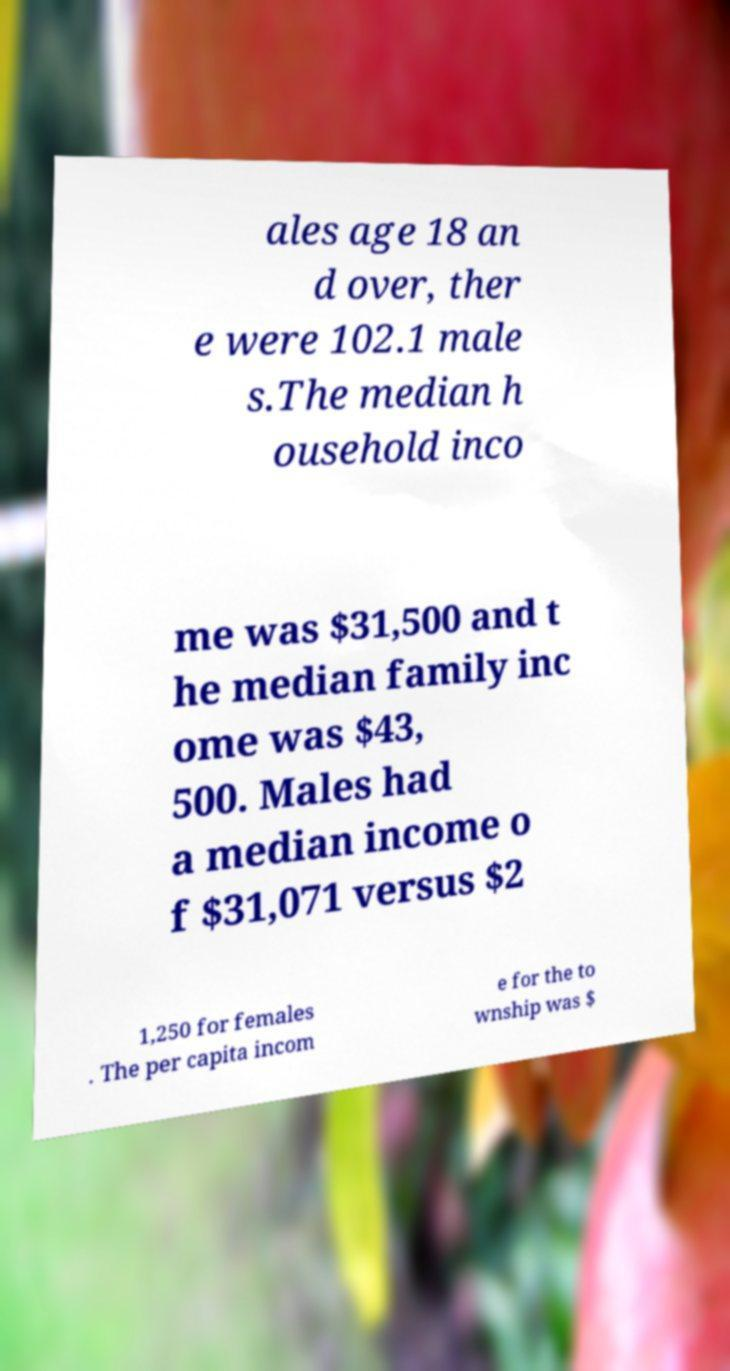Can you read and provide the text displayed in the image?This photo seems to have some interesting text. Can you extract and type it out for me? ales age 18 an d over, ther e were 102.1 male s.The median h ousehold inco me was $31,500 and t he median family inc ome was $43, 500. Males had a median income o f $31,071 versus $2 1,250 for females . The per capita incom e for the to wnship was $ 